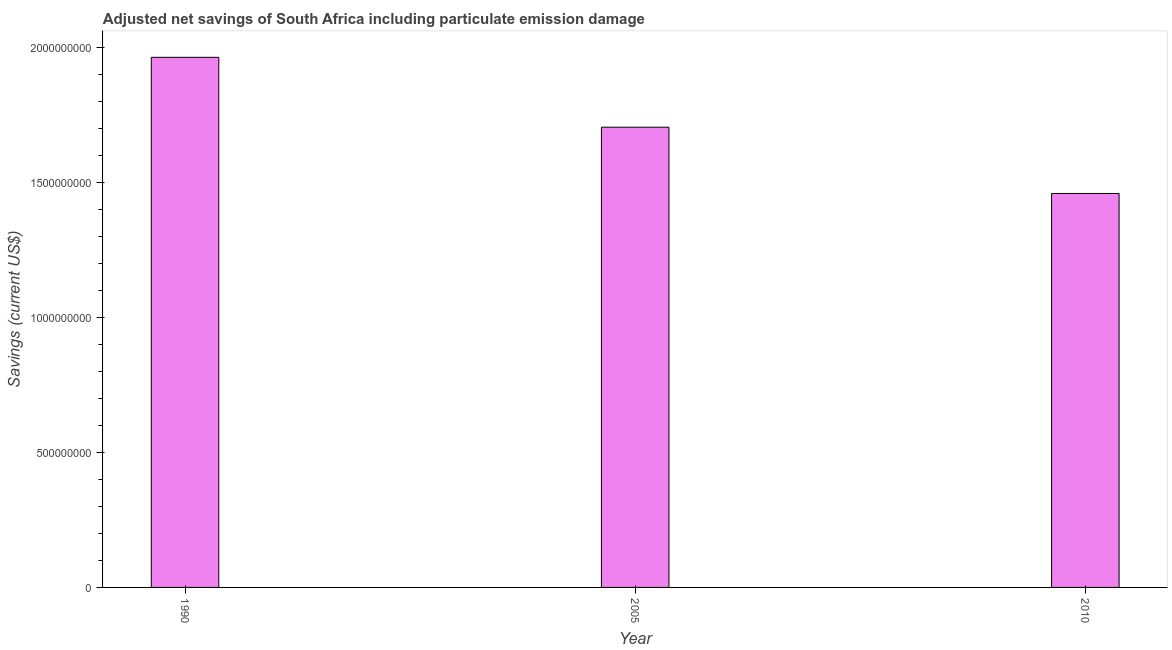Does the graph contain any zero values?
Keep it short and to the point. No. Does the graph contain grids?
Provide a short and direct response. No. What is the title of the graph?
Your answer should be very brief. Adjusted net savings of South Africa including particulate emission damage. What is the label or title of the X-axis?
Your response must be concise. Year. What is the label or title of the Y-axis?
Give a very brief answer. Savings (current US$). What is the adjusted net savings in 1990?
Offer a terse response. 1.96e+09. Across all years, what is the maximum adjusted net savings?
Give a very brief answer. 1.96e+09. Across all years, what is the minimum adjusted net savings?
Make the answer very short. 1.46e+09. In which year was the adjusted net savings maximum?
Provide a short and direct response. 1990. In which year was the adjusted net savings minimum?
Offer a terse response. 2010. What is the sum of the adjusted net savings?
Ensure brevity in your answer.  5.13e+09. What is the difference between the adjusted net savings in 1990 and 2010?
Your response must be concise. 5.05e+08. What is the average adjusted net savings per year?
Offer a terse response. 1.71e+09. What is the median adjusted net savings?
Your answer should be very brief. 1.71e+09. Do a majority of the years between 1990 and 2010 (inclusive) have adjusted net savings greater than 900000000 US$?
Make the answer very short. Yes. What is the ratio of the adjusted net savings in 2005 to that in 2010?
Your answer should be compact. 1.17. Is the adjusted net savings in 1990 less than that in 2010?
Give a very brief answer. No. What is the difference between the highest and the second highest adjusted net savings?
Ensure brevity in your answer.  2.59e+08. What is the difference between the highest and the lowest adjusted net savings?
Provide a short and direct response. 5.05e+08. In how many years, is the adjusted net savings greater than the average adjusted net savings taken over all years?
Offer a terse response. 1. What is the difference between two consecutive major ticks on the Y-axis?
Provide a succinct answer. 5.00e+08. What is the Savings (current US$) of 1990?
Make the answer very short. 1.96e+09. What is the Savings (current US$) in 2005?
Give a very brief answer. 1.71e+09. What is the Savings (current US$) of 2010?
Your response must be concise. 1.46e+09. What is the difference between the Savings (current US$) in 1990 and 2005?
Offer a terse response. 2.59e+08. What is the difference between the Savings (current US$) in 1990 and 2010?
Ensure brevity in your answer.  5.05e+08. What is the difference between the Savings (current US$) in 2005 and 2010?
Your answer should be compact. 2.46e+08. What is the ratio of the Savings (current US$) in 1990 to that in 2005?
Your response must be concise. 1.15. What is the ratio of the Savings (current US$) in 1990 to that in 2010?
Offer a very short reply. 1.35. What is the ratio of the Savings (current US$) in 2005 to that in 2010?
Make the answer very short. 1.17. 